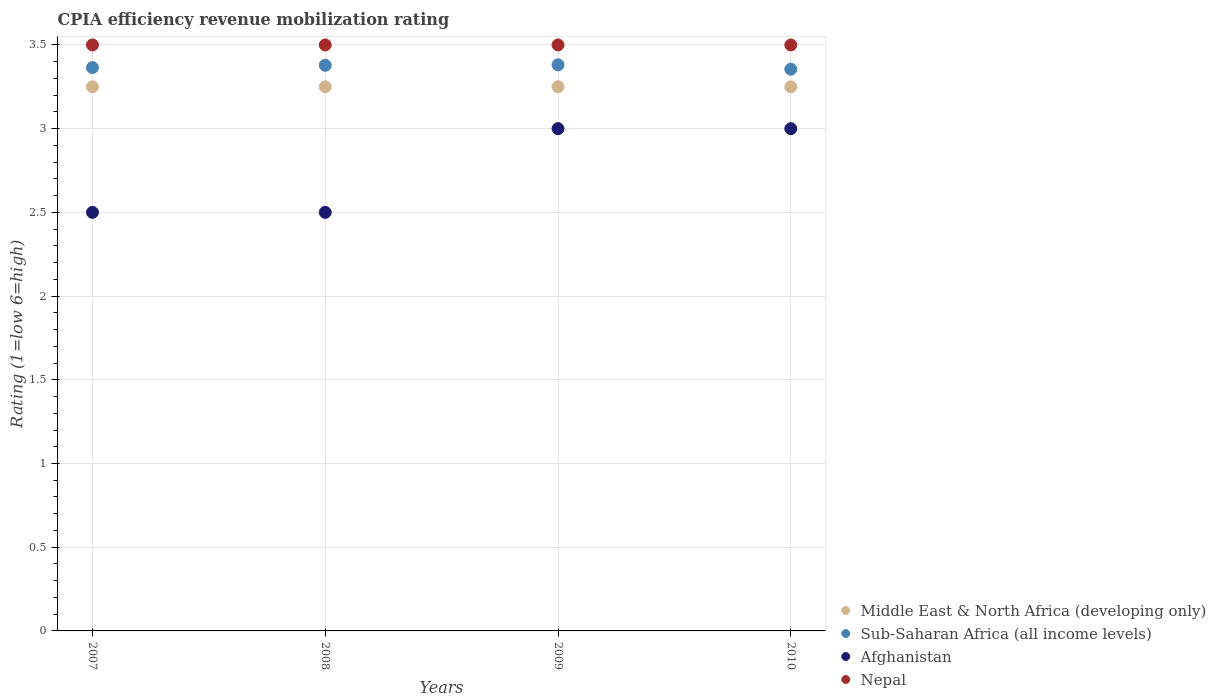How many different coloured dotlines are there?
Keep it short and to the point. 4. Is the number of dotlines equal to the number of legend labels?
Give a very brief answer. Yes. What is the CPIA rating in Nepal in 2007?
Your response must be concise. 3.5. Across all years, what is the minimum CPIA rating in Afghanistan?
Your answer should be very brief. 2.5. In which year was the CPIA rating in Sub-Saharan Africa (all income levels) maximum?
Ensure brevity in your answer.  2009. In which year was the CPIA rating in Sub-Saharan Africa (all income levels) minimum?
Your response must be concise. 2010. What is the difference between the CPIA rating in Sub-Saharan Africa (all income levels) in 2008 and that in 2010?
Keep it short and to the point. 0.02. What is the difference between the CPIA rating in Middle East & North Africa (developing only) in 2007 and the CPIA rating in Sub-Saharan Africa (all income levels) in 2010?
Make the answer very short. -0.11. What is the average CPIA rating in Middle East & North Africa (developing only) per year?
Make the answer very short. 3.25. In the year 2008, what is the difference between the CPIA rating in Sub-Saharan Africa (all income levels) and CPIA rating in Middle East & North Africa (developing only)?
Your response must be concise. 0.13. In how many years, is the CPIA rating in Middle East & North Africa (developing only) greater than 0.9?
Keep it short and to the point. 4. What is the ratio of the CPIA rating in Nepal in 2007 to that in 2008?
Provide a succinct answer. 1. Is the CPIA rating in Sub-Saharan Africa (all income levels) in 2007 less than that in 2009?
Your answer should be very brief. Yes. What is the difference between the highest and the lowest CPIA rating in Sub-Saharan Africa (all income levels)?
Your answer should be compact. 0.03. In how many years, is the CPIA rating in Afghanistan greater than the average CPIA rating in Afghanistan taken over all years?
Your answer should be compact. 2. Is it the case that in every year, the sum of the CPIA rating in Nepal and CPIA rating in Middle East & North Africa (developing only)  is greater than the sum of CPIA rating in Afghanistan and CPIA rating in Sub-Saharan Africa (all income levels)?
Your answer should be compact. Yes. Is the CPIA rating in Middle East & North Africa (developing only) strictly greater than the CPIA rating in Afghanistan over the years?
Offer a terse response. Yes. How many dotlines are there?
Offer a terse response. 4. What is the difference between two consecutive major ticks on the Y-axis?
Your answer should be very brief. 0.5. Are the values on the major ticks of Y-axis written in scientific E-notation?
Your response must be concise. No. Where does the legend appear in the graph?
Offer a terse response. Bottom right. How are the legend labels stacked?
Give a very brief answer. Vertical. What is the title of the graph?
Your response must be concise. CPIA efficiency revenue mobilization rating. What is the label or title of the X-axis?
Give a very brief answer. Years. What is the label or title of the Y-axis?
Your answer should be compact. Rating (1=low 6=high). What is the Rating (1=low 6=high) of Middle East & North Africa (developing only) in 2007?
Provide a short and direct response. 3.25. What is the Rating (1=low 6=high) of Sub-Saharan Africa (all income levels) in 2007?
Offer a very short reply. 3.36. What is the Rating (1=low 6=high) in Afghanistan in 2007?
Your response must be concise. 2.5. What is the Rating (1=low 6=high) of Nepal in 2007?
Provide a short and direct response. 3.5. What is the Rating (1=low 6=high) in Middle East & North Africa (developing only) in 2008?
Offer a very short reply. 3.25. What is the Rating (1=low 6=high) of Sub-Saharan Africa (all income levels) in 2008?
Give a very brief answer. 3.38. What is the Rating (1=low 6=high) in Middle East & North Africa (developing only) in 2009?
Make the answer very short. 3.25. What is the Rating (1=low 6=high) in Sub-Saharan Africa (all income levels) in 2009?
Ensure brevity in your answer.  3.38. What is the Rating (1=low 6=high) in Sub-Saharan Africa (all income levels) in 2010?
Provide a succinct answer. 3.36. What is the Rating (1=low 6=high) in Afghanistan in 2010?
Keep it short and to the point. 3. What is the Rating (1=low 6=high) in Nepal in 2010?
Your response must be concise. 3.5. Across all years, what is the maximum Rating (1=low 6=high) of Middle East & North Africa (developing only)?
Offer a terse response. 3.25. Across all years, what is the maximum Rating (1=low 6=high) of Sub-Saharan Africa (all income levels)?
Your answer should be compact. 3.38. Across all years, what is the maximum Rating (1=low 6=high) in Afghanistan?
Ensure brevity in your answer.  3. Across all years, what is the minimum Rating (1=low 6=high) of Sub-Saharan Africa (all income levels)?
Make the answer very short. 3.36. Across all years, what is the minimum Rating (1=low 6=high) in Nepal?
Give a very brief answer. 3.5. What is the total Rating (1=low 6=high) in Middle East & North Africa (developing only) in the graph?
Your response must be concise. 13. What is the total Rating (1=low 6=high) of Sub-Saharan Africa (all income levels) in the graph?
Ensure brevity in your answer.  13.48. What is the total Rating (1=low 6=high) of Afghanistan in the graph?
Give a very brief answer. 11. What is the total Rating (1=low 6=high) in Nepal in the graph?
Give a very brief answer. 14. What is the difference between the Rating (1=low 6=high) of Middle East & North Africa (developing only) in 2007 and that in 2008?
Provide a succinct answer. 0. What is the difference between the Rating (1=low 6=high) of Sub-Saharan Africa (all income levels) in 2007 and that in 2008?
Provide a short and direct response. -0.01. What is the difference between the Rating (1=low 6=high) of Afghanistan in 2007 and that in 2008?
Make the answer very short. 0. What is the difference between the Rating (1=low 6=high) in Middle East & North Africa (developing only) in 2007 and that in 2009?
Your answer should be very brief. 0. What is the difference between the Rating (1=low 6=high) in Sub-Saharan Africa (all income levels) in 2007 and that in 2009?
Provide a succinct answer. -0.02. What is the difference between the Rating (1=low 6=high) in Afghanistan in 2007 and that in 2009?
Keep it short and to the point. -0.5. What is the difference between the Rating (1=low 6=high) in Middle East & North Africa (developing only) in 2007 and that in 2010?
Offer a terse response. 0. What is the difference between the Rating (1=low 6=high) of Sub-Saharan Africa (all income levels) in 2007 and that in 2010?
Your response must be concise. 0.01. What is the difference between the Rating (1=low 6=high) in Sub-Saharan Africa (all income levels) in 2008 and that in 2009?
Your answer should be compact. -0. What is the difference between the Rating (1=low 6=high) of Nepal in 2008 and that in 2009?
Give a very brief answer. 0. What is the difference between the Rating (1=low 6=high) in Sub-Saharan Africa (all income levels) in 2008 and that in 2010?
Make the answer very short. 0.02. What is the difference between the Rating (1=low 6=high) in Afghanistan in 2008 and that in 2010?
Offer a very short reply. -0.5. What is the difference between the Rating (1=low 6=high) of Nepal in 2008 and that in 2010?
Keep it short and to the point. 0. What is the difference between the Rating (1=low 6=high) of Sub-Saharan Africa (all income levels) in 2009 and that in 2010?
Make the answer very short. 0.03. What is the difference between the Rating (1=low 6=high) of Afghanistan in 2009 and that in 2010?
Give a very brief answer. 0. What is the difference between the Rating (1=low 6=high) of Nepal in 2009 and that in 2010?
Ensure brevity in your answer.  0. What is the difference between the Rating (1=low 6=high) in Middle East & North Africa (developing only) in 2007 and the Rating (1=low 6=high) in Sub-Saharan Africa (all income levels) in 2008?
Your answer should be compact. -0.13. What is the difference between the Rating (1=low 6=high) of Middle East & North Africa (developing only) in 2007 and the Rating (1=low 6=high) of Nepal in 2008?
Keep it short and to the point. -0.25. What is the difference between the Rating (1=low 6=high) in Sub-Saharan Africa (all income levels) in 2007 and the Rating (1=low 6=high) in Afghanistan in 2008?
Give a very brief answer. 0.86. What is the difference between the Rating (1=low 6=high) in Sub-Saharan Africa (all income levels) in 2007 and the Rating (1=low 6=high) in Nepal in 2008?
Offer a very short reply. -0.14. What is the difference between the Rating (1=low 6=high) in Middle East & North Africa (developing only) in 2007 and the Rating (1=low 6=high) in Sub-Saharan Africa (all income levels) in 2009?
Your response must be concise. -0.13. What is the difference between the Rating (1=low 6=high) in Middle East & North Africa (developing only) in 2007 and the Rating (1=low 6=high) in Afghanistan in 2009?
Make the answer very short. 0.25. What is the difference between the Rating (1=low 6=high) of Sub-Saharan Africa (all income levels) in 2007 and the Rating (1=low 6=high) of Afghanistan in 2009?
Provide a short and direct response. 0.36. What is the difference between the Rating (1=low 6=high) in Sub-Saharan Africa (all income levels) in 2007 and the Rating (1=low 6=high) in Nepal in 2009?
Provide a succinct answer. -0.14. What is the difference between the Rating (1=low 6=high) in Afghanistan in 2007 and the Rating (1=low 6=high) in Nepal in 2009?
Your response must be concise. -1. What is the difference between the Rating (1=low 6=high) in Middle East & North Africa (developing only) in 2007 and the Rating (1=low 6=high) in Sub-Saharan Africa (all income levels) in 2010?
Offer a very short reply. -0.11. What is the difference between the Rating (1=low 6=high) of Middle East & North Africa (developing only) in 2007 and the Rating (1=low 6=high) of Nepal in 2010?
Your answer should be very brief. -0.25. What is the difference between the Rating (1=low 6=high) of Sub-Saharan Africa (all income levels) in 2007 and the Rating (1=low 6=high) of Afghanistan in 2010?
Offer a terse response. 0.36. What is the difference between the Rating (1=low 6=high) of Sub-Saharan Africa (all income levels) in 2007 and the Rating (1=low 6=high) of Nepal in 2010?
Your response must be concise. -0.14. What is the difference between the Rating (1=low 6=high) of Afghanistan in 2007 and the Rating (1=low 6=high) of Nepal in 2010?
Your answer should be very brief. -1. What is the difference between the Rating (1=low 6=high) of Middle East & North Africa (developing only) in 2008 and the Rating (1=low 6=high) of Sub-Saharan Africa (all income levels) in 2009?
Ensure brevity in your answer.  -0.13. What is the difference between the Rating (1=low 6=high) in Middle East & North Africa (developing only) in 2008 and the Rating (1=low 6=high) in Afghanistan in 2009?
Provide a succinct answer. 0.25. What is the difference between the Rating (1=low 6=high) in Sub-Saharan Africa (all income levels) in 2008 and the Rating (1=low 6=high) in Afghanistan in 2009?
Offer a very short reply. 0.38. What is the difference between the Rating (1=low 6=high) in Sub-Saharan Africa (all income levels) in 2008 and the Rating (1=low 6=high) in Nepal in 2009?
Ensure brevity in your answer.  -0.12. What is the difference between the Rating (1=low 6=high) in Middle East & North Africa (developing only) in 2008 and the Rating (1=low 6=high) in Sub-Saharan Africa (all income levels) in 2010?
Your response must be concise. -0.11. What is the difference between the Rating (1=low 6=high) of Middle East & North Africa (developing only) in 2008 and the Rating (1=low 6=high) of Afghanistan in 2010?
Give a very brief answer. 0.25. What is the difference between the Rating (1=low 6=high) of Middle East & North Africa (developing only) in 2008 and the Rating (1=low 6=high) of Nepal in 2010?
Provide a succinct answer. -0.25. What is the difference between the Rating (1=low 6=high) of Sub-Saharan Africa (all income levels) in 2008 and the Rating (1=low 6=high) of Afghanistan in 2010?
Make the answer very short. 0.38. What is the difference between the Rating (1=low 6=high) of Sub-Saharan Africa (all income levels) in 2008 and the Rating (1=low 6=high) of Nepal in 2010?
Give a very brief answer. -0.12. What is the difference between the Rating (1=low 6=high) of Middle East & North Africa (developing only) in 2009 and the Rating (1=low 6=high) of Sub-Saharan Africa (all income levels) in 2010?
Provide a short and direct response. -0.11. What is the difference between the Rating (1=low 6=high) of Middle East & North Africa (developing only) in 2009 and the Rating (1=low 6=high) of Nepal in 2010?
Give a very brief answer. -0.25. What is the difference between the Rating (1=low 6=high) in Sub-Saharan Africa (all income levels) in 2009 and the Rating (1=low 6=high) in Afghanistan in 2010?
Your response must be concise. 0.38. What is the difference between the Rating (1=low 6=high) of Sub-Saharan Africa (all income levels) in 2009 and the Rating (1=low 6=high) of Nepal in 2010?
Make the answer very short. -0.12. What is the difference between the Rating (1=low 6=high) of Afghanistan in 2009 and the Rating (1=low 6=high) of Nepal in 2010?
Provide a succinct answer. -0.5. What is the average Rating (1=low 6=high) of Middle East & North Africa (developing only) per year?
Offer a terse response. 3.25. What is the average Rating (1=low 6=high) of Sub-Saharan Africa (all income levels) per year?
Keep it short and to the point. 3.37. What is the average Rating (1=low 6=high) of Afghanistan per year?
Provide a short and direct response. 2.75. In the year 2007, what is the difference between the Rating (1=low 6=high) of Middle East & North Africa (developing only) and Rating (1=low 6=high) of Sub-Saharan Africa (all income levels)?
Offer a terse response. -0.11. In the year 2007, what is the difference between the Rating (1=low 6=high) of Middle East & North Africa (developing only) and Rating (1=low 6=high) of Nepal?
Ensure brevity in your answer.  -0.25. In the year 2007, what is the difference between the Rating (1=low 6=high) in Sub-Saharan Africa (all income levels) and Rating (1=low 6=high) in Afghanistan?
Provide a short and direct response. 0.86. In the year 2007, what is the difference between the Rating (1=low 6=high) of Sub-Saharan Africa (all income levels) and Rating (1=low 6=high) of Nepal?
Provide a short and direct response. -0.14. In the year 2008, what is the difference between the Rating (1=low 6=high) of Middle East & North Africa (developing only) and Rating (1=low 6=high) of Sub-Saharan Africa (all income levels)?
Offer a terse response. -0.13. In the year 2008, what is the difference between the Rating (1=low 6=high) in Sub-Saharan Africa (all income levels) and Rating (1=low 6=high) in Afghanistan?
Your response must be concise. 0.88. In the year 2008, what is the difference between the Rating (1=low 6=high) of Sub-Saharan Africa (all income levels) and Rating (1=low 6=high) of Nepal?
Offer a terse response. -0.12. In the year 2009, what is the difference between the Rating (1=low 6=high) in Middle East & North Africa (developing only) and Rating (1=low 6=high) in Sub-Saharan Africa (all income levels)?
Your answer should be very brief. -0.13. In the year 2009, what is the difference between the Rating (1=low 6=high) of Middle East & North Africa (developing only) and Rating (1=low 6=high) of Afghanistan?
Provide a short and direct response. 0.25. In the year 2009, what is the difference between the Rating (1=low 6=high) of Sub-Saharan Africa (all income levels) and Rating (1=low 6=high) of Afghanistan?
Keep it short and to the point. 0.38. In the year 2009, what is the difference between the Rating (1=low 6=high) in Sub-Saharan Africa (all income levels) and Rating (1=low 6=high) in Nepal?
Provide a short and direct response. -0.12. In the year 2010, what is the difference between the Rating (1=low 6=high) of Middle East & North Africa (developing only) and Rating (1=low 6=high) of Sub-Saharan Africa (all income levels)?
Offer a terse response. -0.11. In the year 2010, what is the difference between the Rating (1=low 6=high) of Middle East & North Africa (developing only) and Rating (1=low 6=high) of Afghanistan?
Your answer should be very brief. 0.25. In the year 2010, what is the difference between the Rating (1=low 6=high) in Sub-Saharan Africa (all income levels) and Rating (1=low 6=high) in Afghanistan?
Your answer should be compact. 0.36. In the year 2010, what is the difference between the Rating (1=low 6=high) of Sub-Saharan Africa (all income levels) and Rating (1=low 6=high) of Nepal?
Give a very brief answer. -0.14. In the year 2010, what is the difference between the Rating (1=low 6=high) in Afghanistan and Rating (1=low 6=high) in Nepal?
Your answer should be compact. -0.5. What is the ratio of the Rating (1=low 6=high) of Sub-Saharan Africa (all income levels) in 2007 to that in 2008?
Give a very brief answer. 1. What is the ratio of the Rating (1=low 6=high) of Afghanistan in 2007 to that in 2008?
Your response must be concise. 1. What is the ratio of the Rating (1=low 6=high) in Afghanistan in 2007 to that in 2009?
Give a very brief answer. 0.83. What is the ratio of the Rating (1=low 6=high) of Nepal in 2007 to that in 2009?
Give a very brief answer. 1. What is the ratio of the Rating (1=low 6=high) of Middle East & North Africa (developing only) in 2007 to that in 2010?
Your answer should be very brief. 1. What is the ratio of the Rating (1=low 6=high) of Afghanistan in 2007 to that in 2010?
Provide a succinct answer. 0.83. What is the ratio of the Rating (1=low 6=high) in Middle East & North Africa (developing only) in 2008 to that in 2009?
Offer a terse response. 1. What is the ratio of the Rating (1=low 6=high) in Sub-Saharan Africa (all income levels) in 2008 to that in 2009?
Your answer should be compact. 1. What is the ratio of the Rating (1=low 6=high) of Afghanistan in 2008 to that in 2009?
Provide a succinct answer. 0.83. What is the ratio of the Rating (1=low 6=high) in Middle East & North Africa (developing only) in 2008 to that in 2010?
Keep it short and to the point. 1. What is the ratio of the Rating (1=low 6=high) in Afghanistan in 2009 to that in 2010?
Keep it short and to the point. 1. What is the difference between the highest and the second highest Rating (1=low 6=high) of Middle East & North Africa (developing only)?
Ensure brevity in your answer.  0. What is the difference between the highest and the second highest Rating (1=low 6=high) of Sub-Saharan Africa (all income levels)?
Offer a very short reply. 0. What is the difference between the highest and the second highest Rating (1=low 6=high) in Afghanistan?
Your response must be concise. 0. What is the difference between the highest and the lowest Rating (1=low 6=high) of Middle East & North Africa (developing only)?
Make the answer very short. 0. What is the difference between the highest and the lowest Rating (1=low 6=high) of Sub-Saharan Africa (all income levels)?
Your response must be concise. 0.03. What is the difference between the highest and the lowest Rating (1=low 6=high) of Afghanistan?
Make the answer very short. 0.5. What is the difference between the highest and the lowest Rating (1=low 6=high) in Nepal?
Keep it short and to the point. 0. 